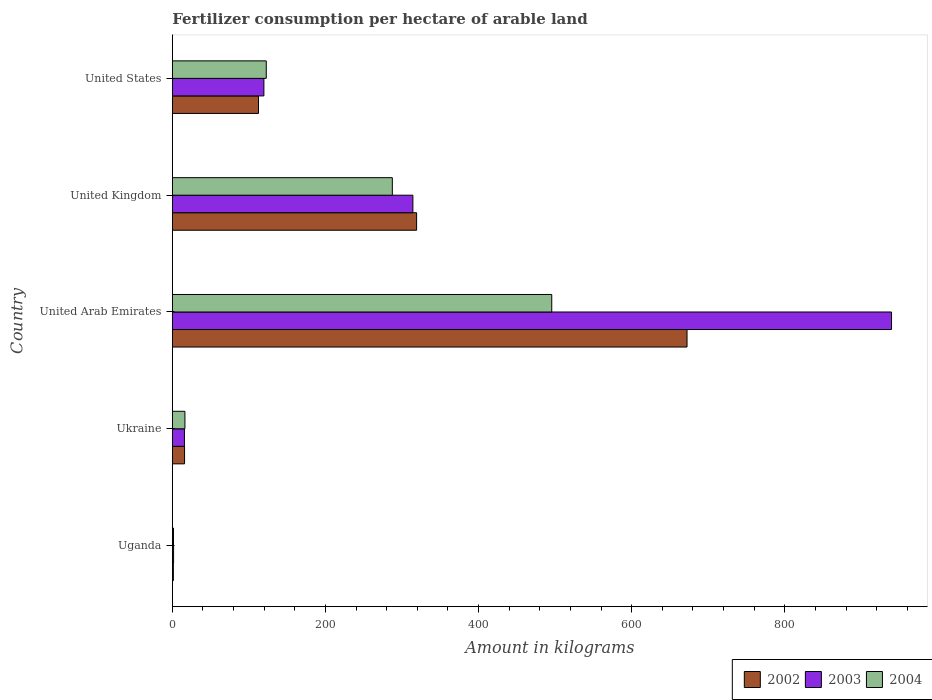How many bars are there on the 3rd tick from the top?
Offer a terse response. 3. What is the label of the 4th group of bars from the top?
Make the answer very short. Ukraine. In how many cases, is the number of bars for a given country not equal to the number of legend labels?
Offer a terse response. 0. What is the amount of fertilizer consumption in 2002 in United Kingdom?
Your response must be concise. 319.05. Across all countries, what is the maximum amount of fertilizer consumption in 2003?
Keep it short and to the point. 939.38. Across all countries, what is the minimum amount of fertilizer consumption in 2003?
Give a very brief answer. 1.6. In which country was the amount of fertilizer consumption in 2003 maximum?
Your answer should be very brief. United Arab Emirates. In which country was the amount of fertilizer consumption in 2003 minimum?
Offer a very short reply. Uganda. What is the total amount of fertilizer consumption in 2004 in the graph?
Give a very brief answer. 923.45. What is the difference between the amount of fertilizer consumption in 2004 in United Kingdom and that in United States?
Your answer should be very brief. 164.66. What is the difference between the amount of fertilizer consumption in 2004 in Ukraine and the amount of fertilizer consumption in 2002 in United Arab Emirates?
Give a very brief answer. -655.85. What is the average amount of fertilizer consumption in 2003 per country?
Provide a succinct answer. 278.1. What is the difference between the amount of fertilizer consumption in 2003 and amount of fertilizer consumption in 2002 in Ukraine?
Make the answer very short. -0.17. What is the ratio of the amount of fertilizer consumption in 2002 in Uganda to that in United States?
Your answer should be compact. 0.01. Is the difference between the amount of fertilizer consumption in 2003 in United Arab Emirates and United Kingdom greater than the difference between the amount of fertilizer consumption in 2002 in United Arab Emirates and United Kingdom?
Your response must be concise. Yes. What is the difference between the highest and the second highest amount of fertilizer consumption in 2002?
Your answer should be very brief. 353.22. What is the difference between the highest and the lowest amount of fertilizer consumption in 2003?
Provide a succinct answer. 937.78. In how many countries, is the amount of fertilizer consumption in 2002 greater than the average amount of fertilizer consumption in 2002 taken over all countries?
Give a very brief answer. 2. What does the 1st bar from the top in United Kingdom represents?
Ensure brevity in your answer.  2004. Is it the case that in every country, the sum of the amount of fertilizer consumption in 2004 and amount of fertilizer consumption in 2002 is greater than the amount of fertilizer consumption in 2003?
Make the answer very short. Yes. Are all the bars in the graph horizontal?
Ensure brevity in your answer.  Yes. Where does the legend appear in the graph?
Keep it short and to the point. Bottom right. How are the legend labels stacked?
Give a very brief answer. Horizontal. What is the title of the graph?
Make the answer very short. Fertilizer consumption per hectare of arable land. Does "1984" appear as one of the legend labels in the graph?
Offer a terse response. No. What is the label or title of the X-axis?
Offer a very short reply. Amount in kilograms. What is the Amount in kilograms in 2002 in Uganda?
Give a very brief answer. 1.33. What is the Amount in kilograms of 2003 in Uganda?
Your answer should be very brief. 1.6. What is the Amount in kilograms in 2004 in Uganda?
Make the answer very short. 1.47. What is the Amount in kilograms in 2002 in Ukraine?
Provide a succinct answer. 15.95. What is the Amount in kilograms in 2003 in Ukraine?
Your answer should be compact. 15.78. What is the Amount in kilograms of 2004 in Ukraine?
Your response must be concise. 16.42. What is the Amount in kilograms in 2002 in United Arab Emirates?
Ensure brevity in your answer.  672.27. What is the Amount in kilograms of 2003 in United Arab Emirates?
Your response must be concise. 939.38. What is the Amount in kilograms of 2004 in United Arab Emirates?
Your answer should be very brief. 495.56. What is the Amount in kilograms of 2002 in United Kingdom?
Keep it short and to the point. 319.05. What is the Amount in kilograms of 2003 in United Kingdom?
Ensure brevity in your answer.  314.19. What is the Amount in kilograms in 2004 in United Kingdom?
Your answer should be compact. 287.33. What is the Amount in kilograms in 2002 in United States?
Provide a short and direct response. 112.52. What is the Amount in kilograms of 2003 in United States?
Provide a short and direct response. 119.56. What is the Amount in kilograms of 2004 in United States?
Provide a short and direct response. 122.67. Across all countries, what is the maximum Amount in kilograms of 2002?
Your answer should be compact. 672.27. Across all countries, what is the maximum Amount in kilograms in 2003?
Make the answer very short. 939.38. Across all countries, what is the maximum Amount in kilograms of 2004?
Your response must be concise. 495.56. Across all countries, what is the minimum Amount in kilograms in 2002?
Offer a terse response. 1.33. Across all countries, what is the minimum Amount in kilograms of 2003?
Provide a succinct answer. 1.6. Across all countries, what is the minimum Amount in kilograms in 2004?
Your answer should be very brief. 1.47. What is the total Amount in kilograms of 2002 in the graph?
Make the answer very short. 1121.12. What is the total Amount in kilograms of 2003 in the graph?
Offer a very short reply. 1390.5. What is the total Amount in kilograms of 2004 in the graph?
Make the answer very short. 923.45. What is the difference between the Amount in kilograms in 2002 in Uganda and that in Ukraine?
Provide a succinct answer. -14.62. What is the difference between the Amount in kilograms in 2003 in Uganda and that in Ukraine?
Ensure brevity in your answer.  -14.18. What is the difference between the Amount in kilograms of 2004 in Uganda and that in Ukraine?
Provide a succinct answer. -14.95. What is the difference between the Amount in kilograms of 2002 in Uganda and that in United Arab Emirates?
Offer a very short reply. -670.93. What is the difference between the Amount in kilograms of 2003 in Uganda and that in United Arab Emirates?
Offer a very short reply. -937.78. What is the difference between the Amount in kilograms of 2004 in Uganda and that in United Arab Emirates?
Your answer should be very brief. -494.08. What is the difference between the Amount in kilograms in 2002 in Uganda and that in United Kingdom?
Your answer should be compact. -317.72. What is the difference between the Amount in kilograms of 2003 in Uganda and that in United Kingdom?
Keep it short and to the point. -312.59. What is the difference between the Amount in kilograms in 2004 in Uganda and that in United Kingdom?
Make the answer very short. -285.86. What is the difference between the Amount in kilograms in 2002 in Uganda and that in United States?
Your response must be concise. -111.18. What is the difference between the Amount in kilograms in 2003 in Uganda and that in United States?
Provide a short and direct response. -117.97. What is the difference between the Amount in kilograms of 2004 in Uganda and that in United States?
Keep it short and to the point. -121.2. What is the difference between the Amount in kilograms of 2002 in Ukraine and that in United Arab Emirates?
Your answer should be compact. -656.32. What is the difference between the Amount in kilograms in 2003 in Ukraine and that in United Arab Emirates?
Give a very brief answer. -923.6. What is the difference between the Amount in kilograms in 2004 in Ukraine and that in United Arab Emirates?
Ensure brevity in your answer.  -479.14. What is the difference between the Amount in kilograms of 2002 in Ukraine and that in United Kingdom?
Keep it short and to the point. -303.1. What is the difference between the Amount in kilograms in 2003 in Ukraine and that in United Kingdom?
Offer a terse response. -298.41. What is the difference between the Amount in kilograms of 2004 in Ukraine and that in United Kingdom?
Keep it short and to the point. -270.92. What is the difference between the Amount in kilograms in 2002 in Ukraine and that in United States?
Ensure brevity in your answer.  -96.57. What is the difference between the Amount in kilograms of 2003 in Ukraine and that in United States?
Offer a terse response. -103.78. What is the difference between the Amount in kilograms of 2004 in Ukraine and that in United States?
Offer a very short reply. -106.25. What is the difference between the Amount in kilograms of 2002 in United Arab Emirates and that in United Kingdom?
Keep it short and to the point. 353.22. What is the difference between the Amount in kilograms in 2003 in United Arab Emirates and that in United Kingdom?
Make the answer very short. 625.19. What is the difference between the Amount in kilograms in 2004 in United Arab Emirates and that in United Kingdom?
Your answer should be very brief. 208.22. What is the difference between the Amount in kilograms in 2002 in United Arab Emirates and that in United States?
Make the answer very short. 559.75. What is the difference between the Amount in kilograms of 2003 in United Arab Emirates and that in United States?
Provide a succinct answer. 819.81. What is the difference between the Amount in kilograms in 2004 in United Arab Emirates and that in United States?
Provide a short and direct response. 372.88. What is the difference between the Amount in kilograms in 2002 in United Kingdom and that in United States?
Ensure brevity in your answer.  206.53. What is the difference between the Amount in kilograms in 2003 in United Kingdom and that in United States?
Keep it short and to the point. 194.63. What is the difference between the Amount in kilograms in 2004 in United Kingdom and that in United States?
Your answer should be very brief. 164.66. What is the difference between the Amount in kilograms in 2002 in Uganda and the Amount in kilograms in 2003 in Ukraine?
Offer a terse response. -14.45. What is the difference between the Amount in kilograms in 2002 in Uganda and the Amount in kilograms in 2004 in Ukraine?
Your response must be concise. -15.09. What is the difference between the Amount in kilograms in 2003 in Uganda and the Amount in kilograms in 2004 in Ukraine?
Provide a succinct answer. -14.82. What is the difference between the Amount in kilograms of 2002 in Uganda and the Amount in kilograms of 2003 in United Arab Emirates?
Your response must be concise. -938.04. What is the difference between the Amount in kilograms in 2002 in Uganda and the Amount in kilograms in 2004 in United Arab Emirates?
Your answer should be compact. -494.22. What is the difference between the Amount in kilograms in 2003 in Uganda and the Amount in kilograms in 2004 in United Arab Emirates?
Offer a very short reply. -493.96. What is the difference between the Amount in kilograms of 2002 in Uganda and the Amount in kilograms of 2003 in United Kingdom?
Your answer should be compact. -312.86. What is the difference between the Amount in kilograms in 2002 in Uganda and the Amount in kilograms in 2004 in United Kingdom?
Offer a terse response. -286. What is the difference between the Amount in kilograms of 2003 in Uganda and the Amount in kilograms of 2004 in United Kingdom?
Ensure brevity in your answer.  -285.74. What is the difference between the Amount in kilograms of 2002 in Uganda and the Amount in kilograms of 2003 in United States?
Provide a succinct answer. -118.23. What is the difference between the Amount in kilograms of 2002 in Uganda and the Amount in kilograms of 2004 in United States?
Your response must be concise. -121.34. What is the difference between the Amount in kilograms in 2003 in Uganda and the Amount in kilograms in 2004 in United States?
Offer a terse response. -121.08. What is the difference between the Amount in kilograms in 2002 in Ukraine and the Amount in kilograms in 2003 in United Arab Emirates?
Make the answer very short. -923.43. What is the difference between the Amount in kilograms of 2002 in Ukraine and the Amount in kilograms of 2004 in United Arab Emirates?
Offer a terse response. -479.61. What is the difference between the Amount in kilograms of 2003 in Ukraine and the Amount in kilograms of 2004 in United Arab Emirates?
Offer a very short reply. -479.78. What is the difference between the Amount in kilograms of 2002 in Ukraine and the Amount in kilograms of 2003 in United Kingdom?
Give a very brief answer. -298.24. What is the difference between the Amount in kilograms in 2002 in Ukraine and the Amount in kilograms in 2004 in United Kingdom?
Your answer should be very brief. -271.39. What is the difference between the Amount in kilograms in 2003 in Ukraine and the Amount in kilograms in 2004 in United Kingdom?
Your response must be concise. -271.56. What is the difference between the Amount in kilograms of 2002 in Ukraine and the Amount in kilograms of 2003 in United States?
Offer a terse response. -103.61. What is the difference between the Amount in kilograms of 2002 in Ukraine and the Amount in kilograms of 2004 in United States?
Give a very brief answer. -106.72. What is the difference between the Amount in kilograms in 2003 in Ukraine and the Amount in kilograms in 2004 in United States?
Give a very brief answer. -106.89. What is the difference between the Amount in kilograms in 2002 in United Arab Emirates and the Amount in kilograms in 2003 in United Kingdom?
Make the answer very short. 358.08. What is the difference between the Amount in kilograms of 2002 in United Arab Emirates and the Amount in kilograms of 2004 in United Kingdom?
Provide a succinct answer. 384.93. What is the difference between the Amount in kilograms in 2003 in United Arab Emirates and the Amount in kilograms in 2004 in United Kingdom?
Your answer should be very brief. 652.04. What is the difference between the Amount in kilograms of 2002 in United Arab Emirates and the Amount in kilograms of 2003 in United States?
Your answer should be very brief. 552.71. What is the difference between the Amount in kilograms of 2002 in United Arab Emirates and the Amount in kilograms of 2004 in United States?
Keep it short and to the point. 549.6. What is the difference between the Amount in kilograms of 2003 in United Arab Emirates and the Amount in kilograms of 2004 in United States?
Your answer should be very brief. 816.7. What is the difference between the Amount in kilograms in 2002 in United Kingdom and the Amount in kilograms in 2003 in United States?
Provide a succinct answer. 199.49. What is the difference between the Amount in kilograms in 2002 in United Kingdom and the Amount in kilograms in 2004 in United States?
Your answer should be very brief. 196.38. What is the difference between the Amount in kilograms in 2003 in United Kingdom and the Amount in kilograms in 2004 in United States?
Offer a terse response. 191.52. What is the average Amount in kilograms of 2002 per country?
Keep it short and to the point. 224.22. What is the average Amount in kilograms in 2003 per country?
Your answer should be very brief. 278.1. What is the average Amount in kilograms of 2004 per country?
Give a very brief answer. 184.69. What is the difference between the Amount in kilograms of 2002 and Amount in kilograms of 2003 in Uganda?
Provide a succinct answer. -0.26. What is the difference between the Amount in kilograms of 2002 and Amount in kilograms of 2004 in Uganda?
Your answer should be compact. -0.14. What is the difference between the Amount in kilograms of 2003 and Amount in kilograms of 2004 in Uganda?
Provide a succinct answer. 0.12. What is the difference between the Amount in kilograms of 2002 and Amount in kilograms of 2003 in Ukraine?
Offer a very short reply. 0.17. What is the difference between the Amount in kilograms of 2002 and Amount in kilograms of 2004 in Ukraine?
Offer a very short reply. -0.47. What is the difference between the Amount in kilograms in 2003 and Amount in kilograms in 2004 in Ukraine?
Offer a terse response. -0.64. What is the difference between the Amount in kilograms in 2002 and Amount in kilograms in 2003 in United Arab Emirates?
Offer a terse response. -267.11. What is the difference between the Amount in kilograms in 2002 and Amount in kilograms in 2004 in United Arab Emirates?
Offer a very short reply. 176.71. What is the difference between the Amount in kilograms in 2003 and Amount in kilograms in 2004 in United Arab Emirates?
Ensure brevity in your answer.  443.82. What is the difference between the Amount in kilograms in 2002 and Amount in kilograms in 2003 in United Kingdom?
Your answer should be very brief. 4.86. What is the difference between the Amount in kilograms in 2002 and Amount in kilograms in 2004 in United Kingdom?
Ensure brevity in your answer.  31.72. What is the difference between the Amount in kilograms in 2003 and Amount in kilograms in 2004 in United Kingdom?
Your response must be concise. 26.86. What is the difference between the Amount in kilograms in 2002 and Amount in kilograms in 2003 in United States?
Offer a very short reply. -7.04. What is the difference between the Amount in kilograms in 2002 and Amount in kilograms in 2004 in United States?
Your response must be concise. -10.15. What is the difference between the Amount in kilograms in 2003 and Amount in kilograms in 2004 in United States?
Keep it short and to the point. -3.11. What is the ratio of the Amount in kilograms of 2002 in Uganda to that in Ukraine?
Give a very brief answer. 0.08. What is the ratio of the Amount in kilograms of 2003 in Uganda to that in Ukraine?
Your response must be concise. 0.1. What is the ratio of the Amount in kilograms in 2004 in Uganda to that in Ukraine?
Give a very brief answer. 0.09. What is the ratio of the Amount in kilograms in 2002 in Uganda to that in United Arab Emirates?
Provide a succinct answer. 0. What is the ratio of the Amount in kilograms of 2003 in Uganda to that in United Arab Emirates?
Offer a very short reply. 0. What is the ratio of the Amount in kilograms in 2004 in Uganda to that in United Arab Emirates?
Ensure brevity in your answer.  0. What is the ratio of the Amount in kilograms in 2002 in Uganda to that in United Kingdom?
Your answer should be compact. 0. What is the ratio of the Amount in kilograms in 2003 in Uganda to that in United Kingdom?
Provide a succinct answer. 0.01. What is the ratio of the Amount in kilograms in 2004 in Uganda to that in United Kingdom?
Your answer should be very brief. 0.01. What is the ratio of the Amount in kilograms of 2002 in Uganda to that in United States?
Provide a succinct answer. 0.01. What is the ratio of the Amount in kilograms in 2003 in Uganda to that in United States?
Offer a terse response. 0.01. What is the ratio of the Amount in kilograms in 2004 in Uganda to that in United States?
Provide a succinct answer. 0.01. What is the ratio of the Amount in kilograms in 2002 in Ukraine to that in United Arab Emirates?
Your response must be concise. 0.02. What is the ratio of the Amount in kilograms of 2003 in Ukraine to that in United Arab Emirates?
Keep it short and to the point. 0.02. What is the ratio of the Amount in kilograms of 2004 in Ukraine to that in United Arab Emirates?
Your answer should be very brief. 0.03. What is the ratio of the Amount in kilograms in 2003 in Ukraine to that in United Kingdom?
Keep it short and to the point. 0.05. What is the ratio of the Amount in kilograms in 2004 in Ukraine to that in United Kingdom?
Keep it short and to the point. 0.06. What is the ratio of the Amount in kilograms in 2002 in Ukraine to that in United States?
Your answer should be very brief. 0.14. What is the ratio of the Amount in kilograms in 2003 in Ukraine to that in United States?
Give a very brief answer. 0.13. What is the ratio of the Amount in kilograms of 2004 in Ukraine to that in United States?
Provide a short and direct response. 0.13. What is the ratio of the Amount in kilograms of 2002 in United Arab Emirates to that in United Kingdom?
Offer a very short reply. 2.11. What is the ratio of the Amount in kilograms of 2003 in United Arab Emirates to that in United Kingdom?
Your answer should be compact. 2.99. What is the ratio of the Amount in kilograms in 2004 in United Arab Emirates to that in United Kingdom?
Your answer should be very brief. 1.72. What is the ratio of the Amount in kilograms in 2002 in United Arab Emirates to that in United States?
Make the answer very short. 5.97. What is the ratio of the Amount in kilograms in 2003 in United Arab Emirates to that in United States?
Keep it short and to the point. 7.86. What is the ratio of the Amount in kilograms of 2004 in United Arab Emirates to that in United States?
Ensure brevity in your answer.  4.04. What is the ratio of the Amount in kilograms of 2002 in United Kingdom to that in United States?
Ensure brevity in your answer.  2.84. What is the ratio of the Amount in kilograms of 2003 in United Kingdom to that in United States?
Make the answer very short. 2.63. What is the ratio of the Amount in kilograms of 2004 in United Kingdom to that in United States?
Your answer should be compact. 2.34. What is the difference between the highest and the second highest Amount in kilograms of 2002?
Provide a succinct answer. 353.22. What is the difference between the highest and the second highest Amount in kilograms of 2003?
Provide a succinct answer. 625.19. What is the difference between the highest and the second highest Amount in kilograms of 2004?
Make the answer very short. 208.22. What is the difference between the highest and the lowest Amount in kilograms of 2002?
Provide a succinct answer. 670.93. What is the difference between the highest and the lowest Amount in kilograms in 2003?
Your answer should be compact. 937.78. What is the difference between the highest and the lowest Amount in kilograms in 2004?
Offer a very short reply. 494.08. 